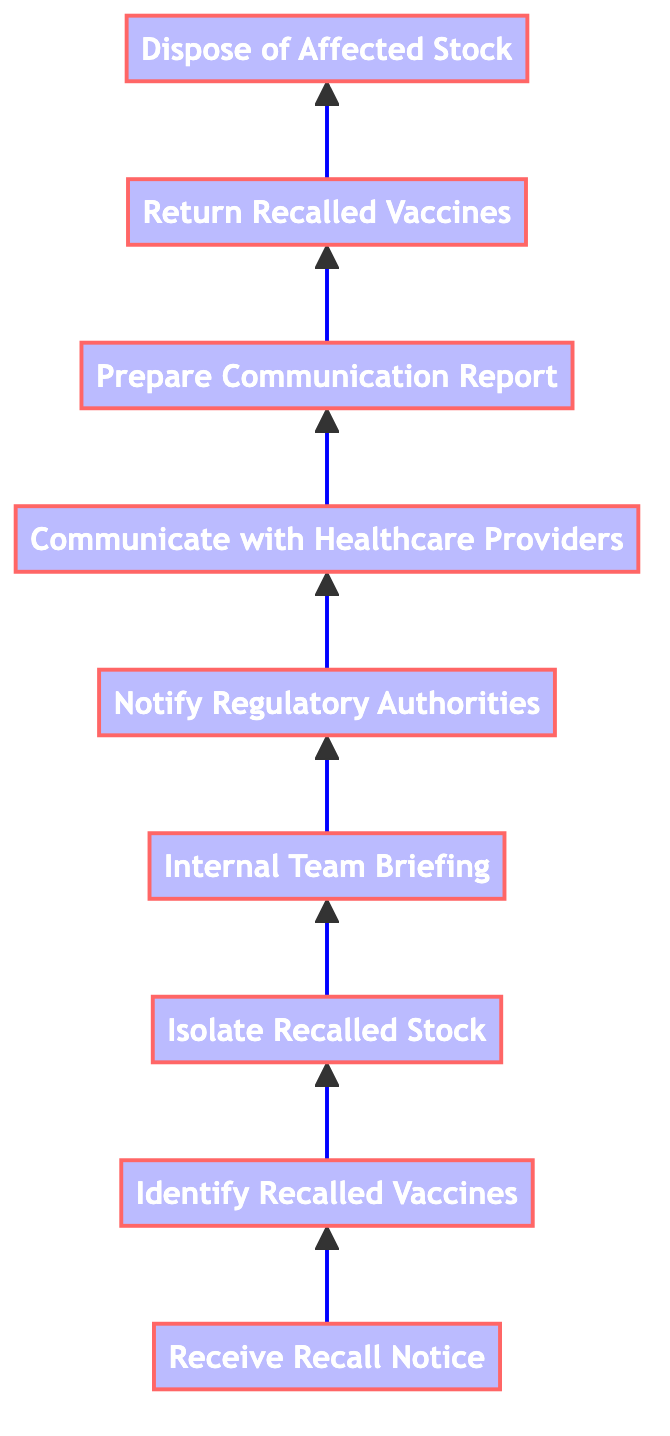What is the first step in the vaccine recall process? The first step, as indicated in the diagram, is "Receive Recall Notice." This step starts the entire process of handling a vaccine recall.
Answer: Receive Recall Notice How many total steps are in the vaccine recall process? By counting all the distinct steps listed in the diagram, there are nine total steps involved in the vaccine recall process.
Answer: 9 What is the last step after "Return Recalled Vaccines"? The step that follows "Return Recalled Vaccines" is "Dispose of Affected Stock," indicating the final action after returning the recalled vaccines.
Answer: Dispose of Affected Stock Which step directly follows "Isolate Recalled Stock"? The step that directly follows "Isolate Recalled Stock" is "Internal Team Briefing." This indicates the need for team communication after isolating the recalled products.
Answer: Internal Team Briefing Which authorities need to be notified according to the diagram? The diagram specifies that "Regulatory Authorities" need to be notified during the recall process. This step emphasizes the importance of informing the authorities about the situation.
Answer: Regulatory Authorities What is the relationship between "Identify Recalled Vaccines" and "Isolate Recalled Stock"? "Identify Recalled Vaccines" comes before "Isolate Recalled Stock," indicating that one must first identify the specific recalled items before taking measures to isolate them.
Answer: Identify Recalled Vaccines → Isolate Recalled Stock What is the primary purpose of "Prepare Communication Report"? The primary purpose of "Prepare Communication Report" is to compile a detailed summary of the recall process and actions taken for future reference, thus ensuring clarity and documentation.
Answer: Compile a detailed report Which step indicates actions to be taken with recalled vaccines? The step that indicates actions to be taken with recalled vaccines is "Return Recalled Vaccines." This step involves coordinating the return of the affected products to the manufacturer or distributor.
Answer: Return Recalled Vaccines What step occurs right before notifying healthcare providers? The step that occurs right before notifying healthcare providers is "Notify Regulatory Authorities," suggesting that informing the authorities is prioritized before reaching out to healthcare practitioners.
Answer: Notify Regulatory Authorities 